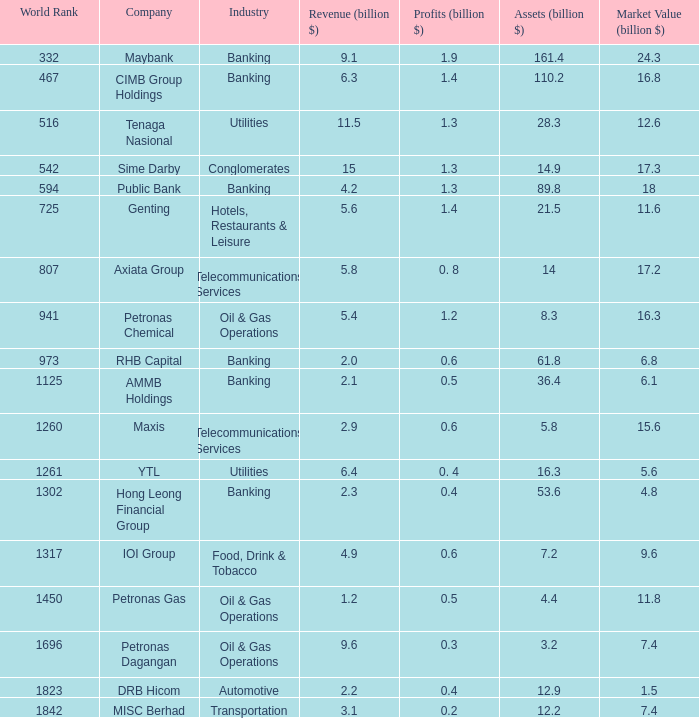Identify the market worth for rhb capital. 6.8. 